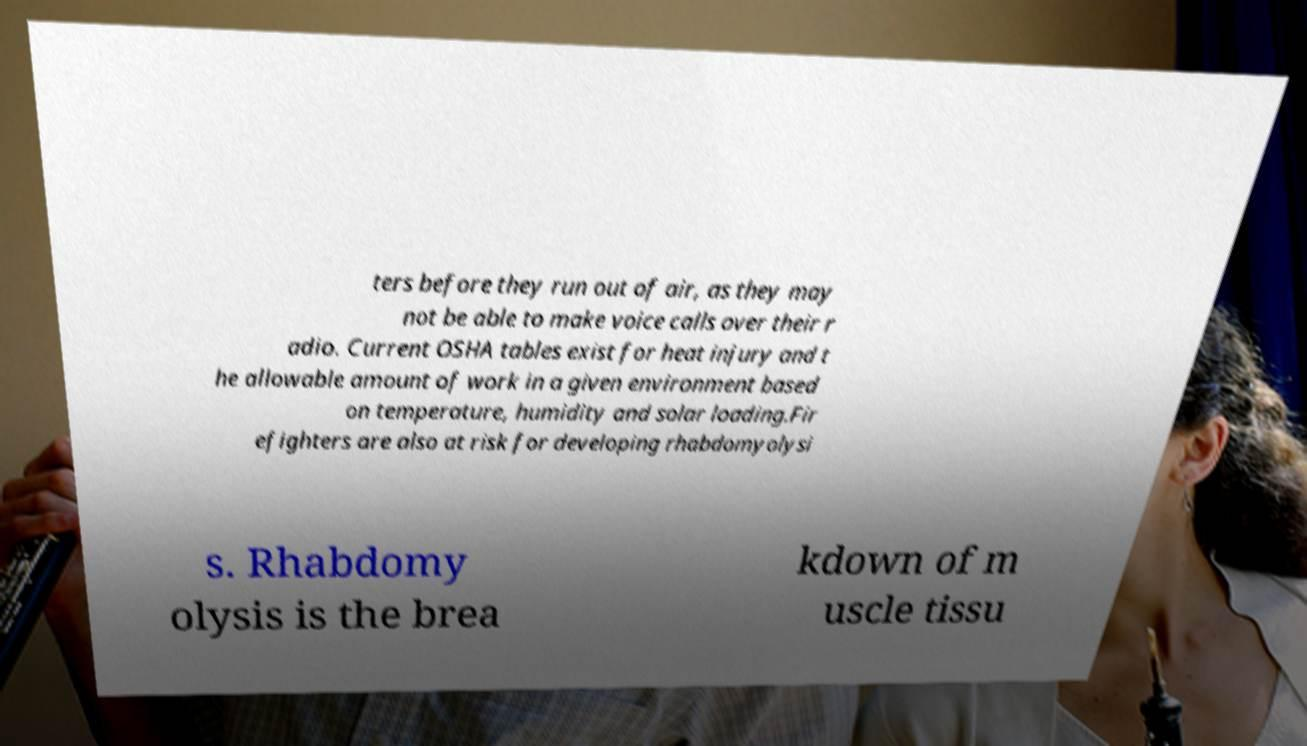Please read and relay the text visible in this image. What does it say? ters before they run out of air, as they may not be able to make voice calls over their r adio. Current OSHA tables exist for heat injury and t he allowable amount of work in a given environment based on temperature, humidity and solar loading.Fir efighters are also at risk for developing rhabdomyolysi s. Rhabdomy olysis is the brea kdown of m uscle tissu 